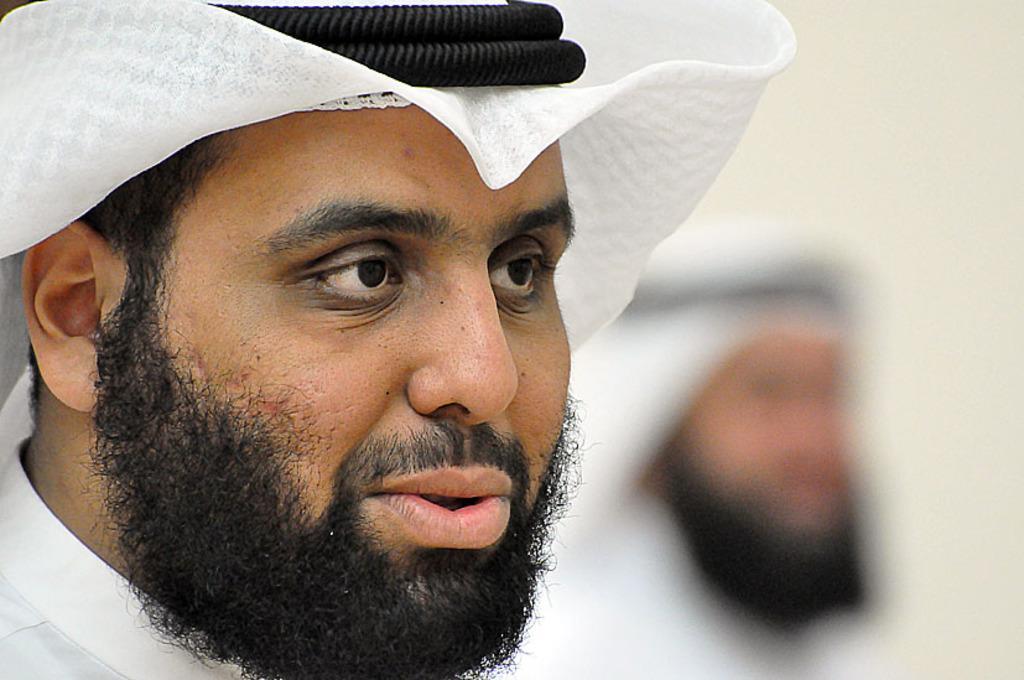Please provide a concise description of this image. To the left side of the image there is a man in white dress. He is having beard. On his head there is a white cloth and black rings. To the right side of the image there is a blur image with a person. 